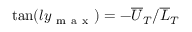Convert formula to latex. <formula><loc_0><loc_0><loc_500><loc_500>\tan ( l y _ { m a x } ) = - { \overline { U } _ { T } } / { \overline { L } _ { T } }</formula> 